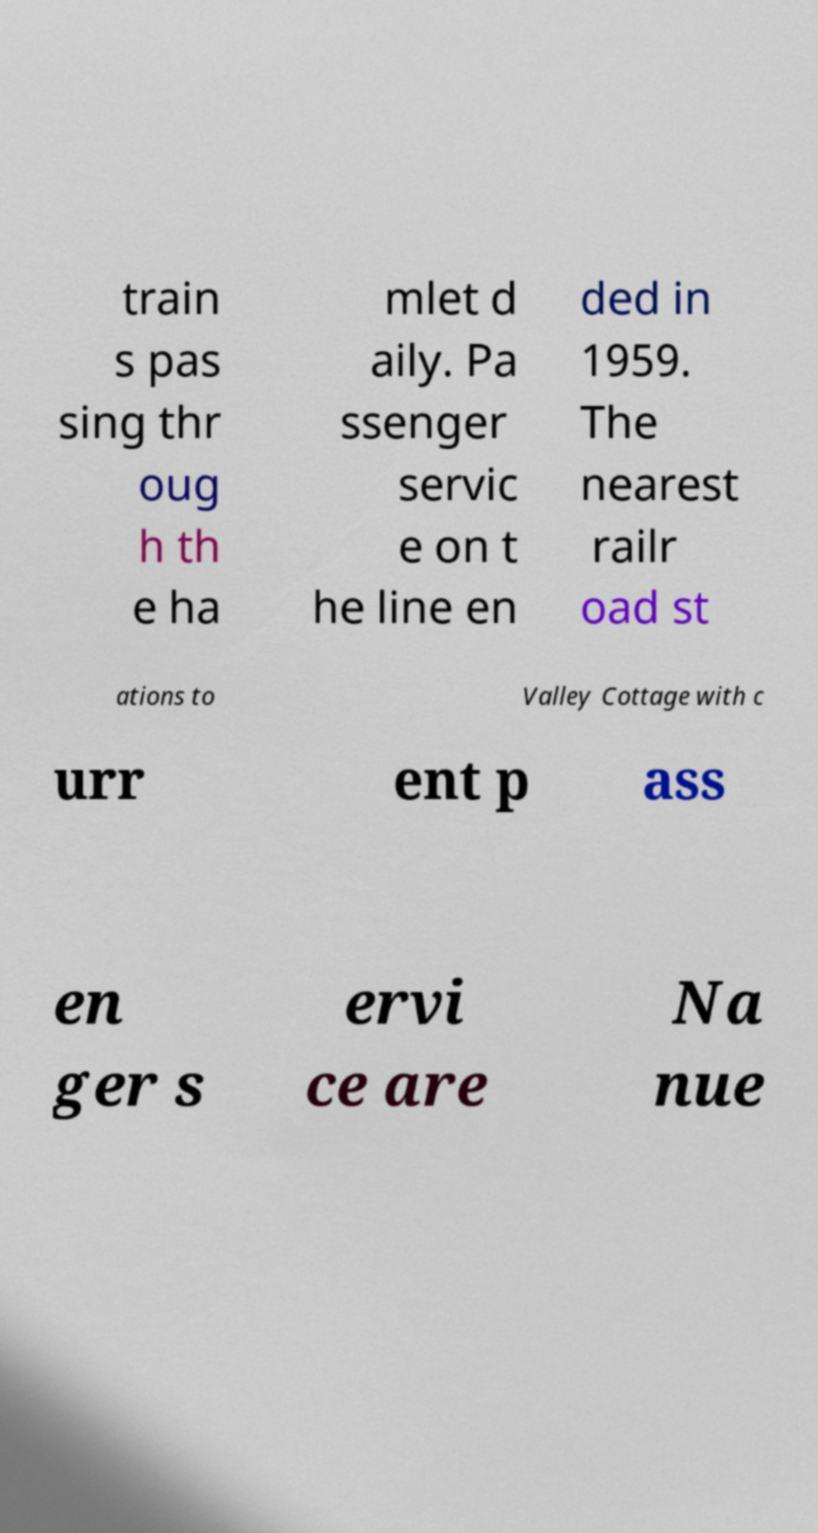I need the written content from this picture converted into text. Can you do that? train s pas sing thr oug h th e ha mlet d aily. Pa ssenger servic e on t he line en ded in 1959. The nearest railr oad st ations to Valley Cottage with c urr ent p ass en ger s ervi ce are Na nue 